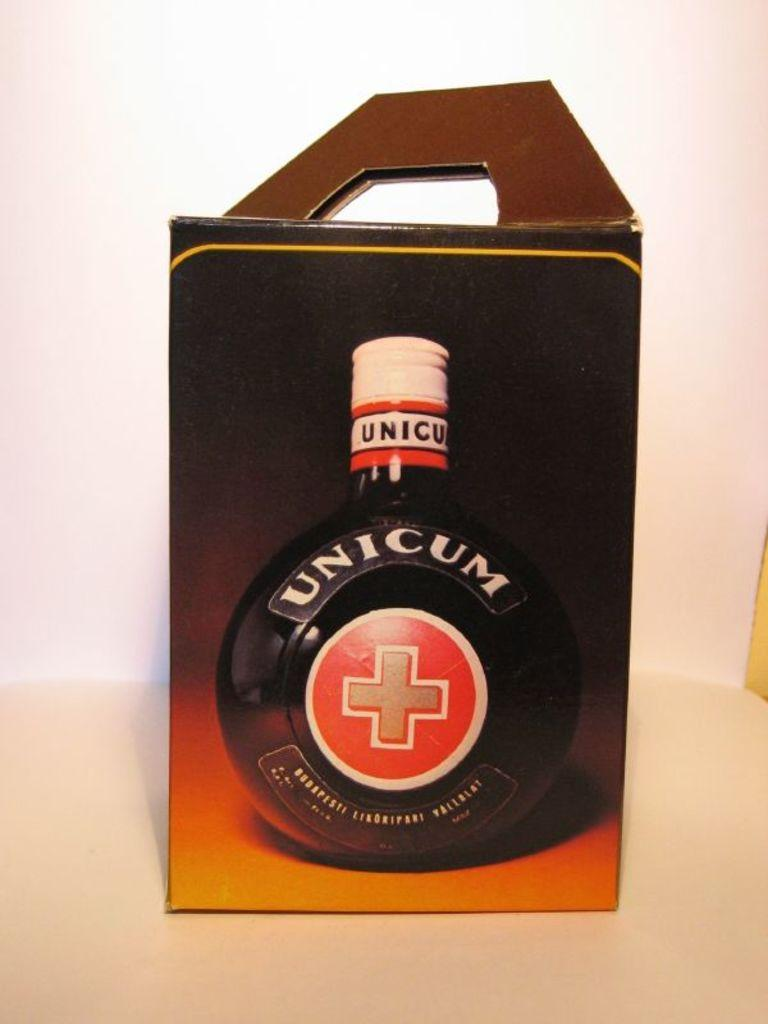Provide a one-sentence caption for the provided image. A box of Unicom is seen against a pink and white background. 